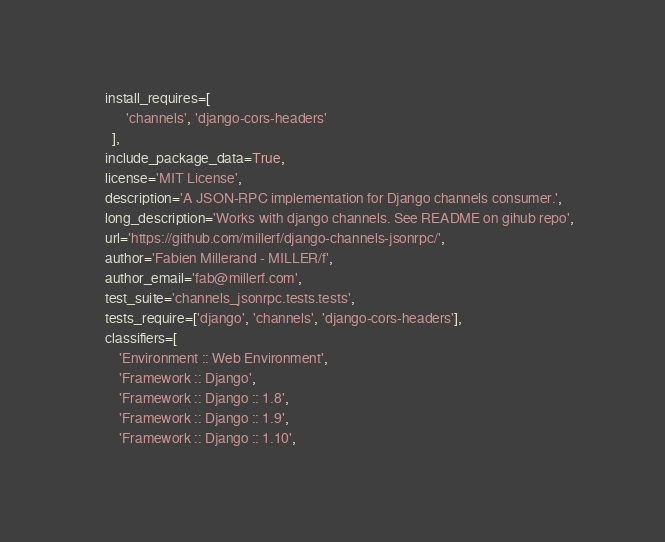<code> <loc_0><loc_0><loc_500><loc_500><_Python_>    install_requires=[
          'channels', 'django-cors-headers'
      ],
    include_package_data=True,
    license='MIT License',
    description='A JSON-RPC implementation for Django channels consumer.',
    long_description='Works with django channels. See README on gihub repo',
    url='https://github.com/millerf/django-channels-jsonrpc/',
    author='Fabien Millerand - MILLER/f',
    author_email='fab@millerf.com',
    test_suite='channels_jsonrpc.tests.tests',
    tests_require=['django', 'channels', 'django-cors-headers'],
    classifiers=[
        'Environment :: Web Environment',
        'Framework :: Django',
        'Framework :: Django :: 1.8',
        'Framework :: Django :: 1.9',
        'Framework :: Django :: 1.10',</code> 